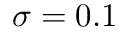<formula> <loc_0><loc_0><loc_500><loc_500>\sigma = 0 . 1</formula> 